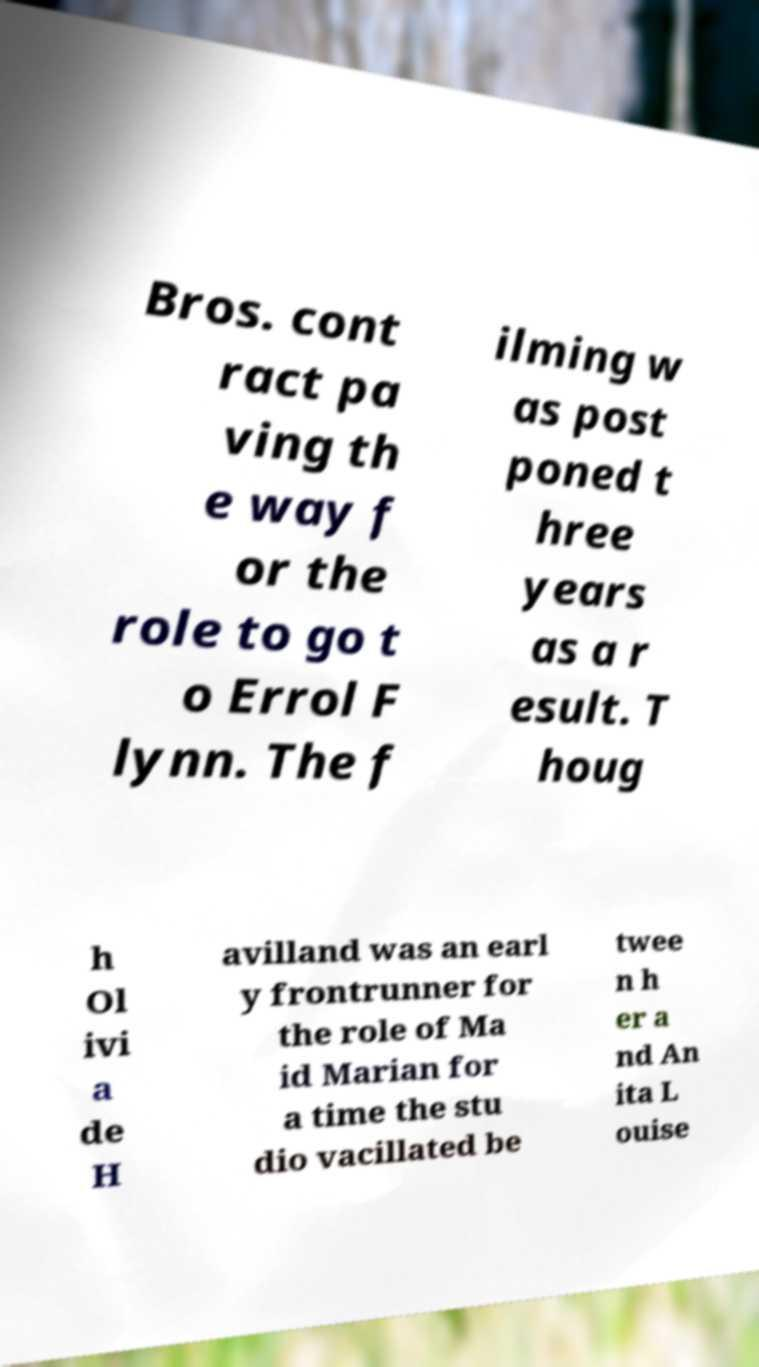For documentation purposes, I need the text within this image transcribed. Could you provide that? Bros. cont ract pa ving th e way f or the role to go t o Errol F lynn. The f ilming w as post poned t hree years as a r esult. T houg h Ol ivi a de H avilland was an earl y frontrunner for the role of Ma id Marian for a time the stu dio vacillated be twee n h er a nd An ita L ouise 